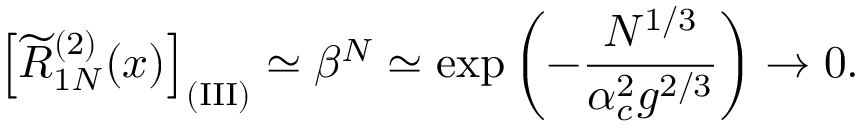<formula> <loc_0><loc_0><loc_500><loc_500>\left [ \widetilde { R } _ { 1 N } ^ { ( 2 ) } ( x ) \right ] _ { ( I I I ) } \simeq \beta ^ { N } \simeq \exp \left ( - { \frac { N ^ { 1 / 3 } } { \alpha _ { c } ^ { 2 } g ^ { 2 / 3 } } } \right ) \rightarrow 0 .</formula> 